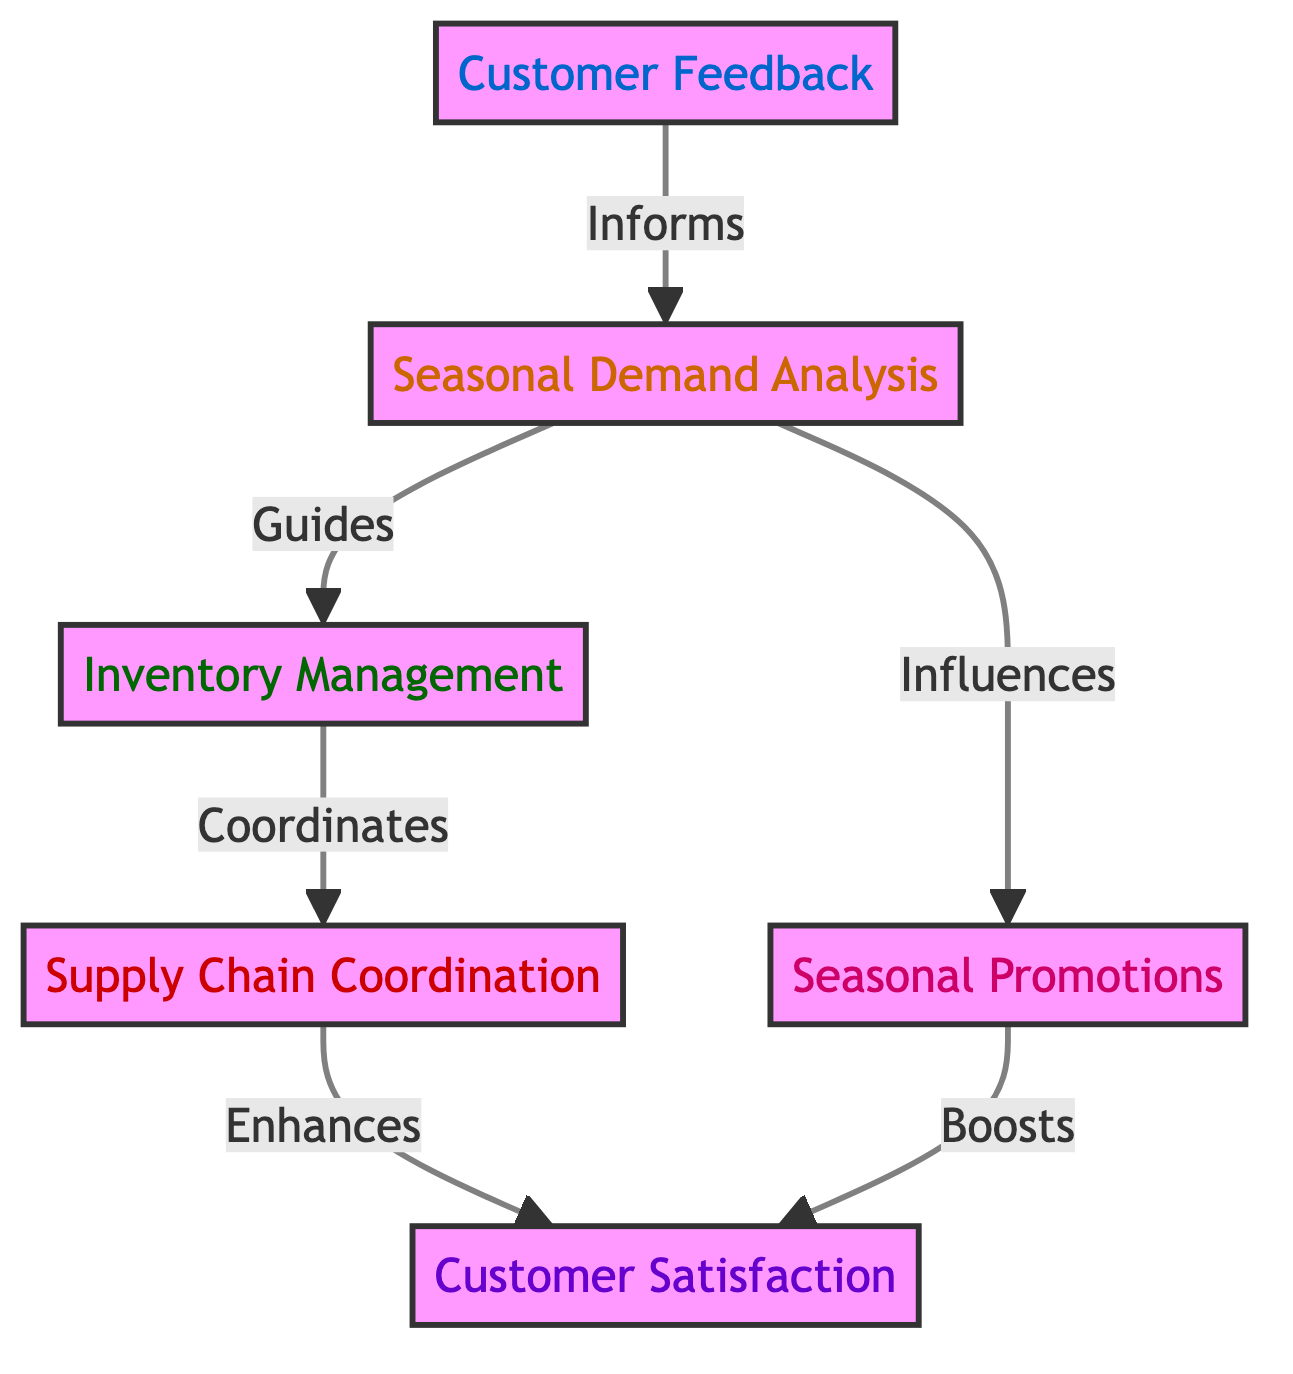What is the starting point of the flow in the diagram? The flowchart starts with "Customer Feedback," which is the first node in the sequence.
Answer: Customer Feedback How many main nodes are in the diagram? There are six main nodes in the diagram, which represent different stages in the flow.
Answer: 6 What does "Seasonal Demand Analysis" influence in the diagram? "Seasonal Demand Analysis" influences both "Inventory Management" and "Seasonal Promotions," as shown by the directed arrows from this node to both of those nodes.
Answer: Seasonal Promotions Which node enhances customer satisfaction? "Supply Chain Coordination" is the node that enhances "Customer Satisfaction."
Answer: Supply Chain Coordination What is the relationship between "Customer Feedback" and "Seasonal Promotions"? "Customer Feedback" informs "Seasonal Demand Analysis," which influences "Seasonal Promotions," establishing a indirect relationship between the two nodes.
Answer: Influences What does "Inventory Management" coordinate with in the diagram? "Inventory Management" coordinates with "Supply Chain Coordination," as indicated by the arrow leading from Inventory Management to Supply Chain Coordination.
Answer: Supply Chain Coordination Which two nodes are directly connected to "Seasonal Demand Analysis"? "Customer Feedback" and "Seasonal Promotions." The arrows indicate that these two nodes directly connect to "Seasonal Demand Analysis."
Answer: Customer Feedback, Seasonal Promotions How does "Seasonal Promotions" affect customer satisfaction? "Seasonal Promotions" boosts "Customer Satisfaction," which is shown by the directed arrow going from "Seasonal Promotions" to "Customer Satisfaction."
Answer: Boosts What color represents the "Customer Satisfaction" node in the diagram? The node for "Customer Satisfaction" is colored lavender or purple, specifically hex color #f0e6ff, based on its visual representation.
Answer: Lavender 